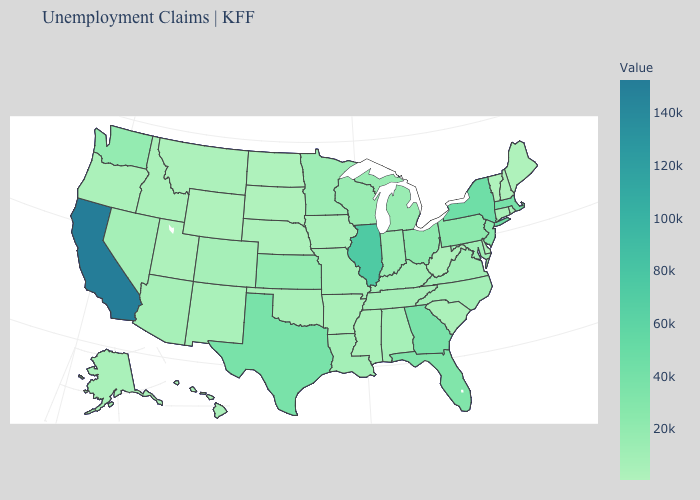Which states hav the highest value in the South?
Be succinct. Texas. Among the states that border Virginia , does Maryland have the lowest value?
Quick response, please. No. Does Maryland have a higher value than Massachusetts?
Give a very brief answer. No. Does the map have missing data?
Keep it brief. No. Does Delaware have the lowest value in the South?
Write a very short answer. Yes. Which states have the lowest value in the USA?
Write a very short answer. Vermont. 